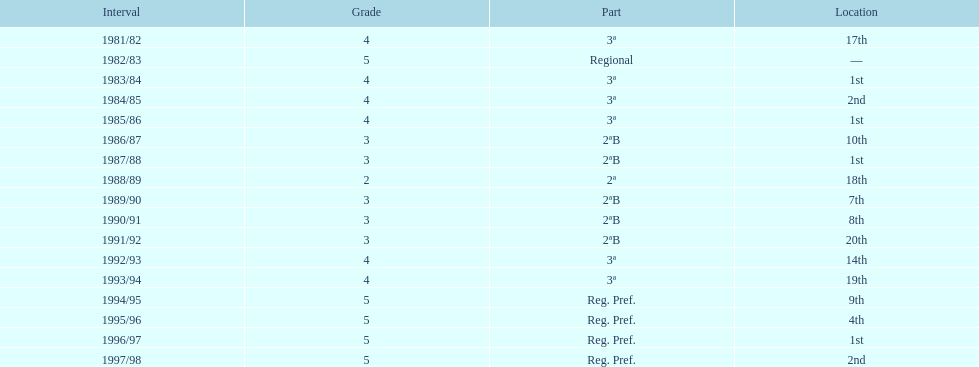How many seasons are shown in this chart? 17. 